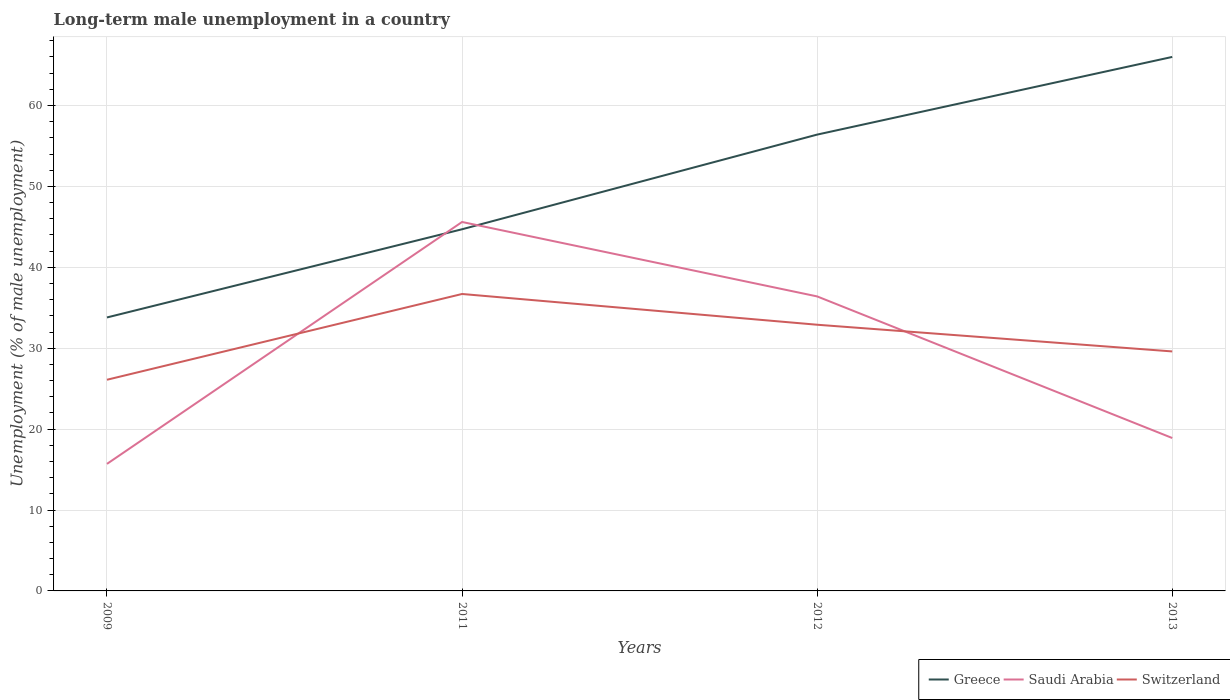Does the line corresponding to Saudi Arabia intersect with the line corresponding to Switzerland?
Give a very brief answer. Yes. Is the number of lines equal to the number of legend labels?
Provide a short and direct response. Yes. Across all years, what is the maximum percentage of long-term unemployed male population in Saudi Arabia?
Your response must be concise. 15.7. What is the total percentage of long-term unemployed male population in Greece in the graph?
Make the answer very short. -21.3. What is the difference between the highest and the second highest percentage of long-term unemployed male population in Switzerland?
Give a very brief answer. 10.6. How many lines are there?
Your response must be concise. 3. Does the graph contain any zero values?
Provide a succinct answer. No. Where does the legend appear in the graph?
Your answer should be very brief. Bottom right. How many legend labels are there?
Offer a terse response. 3. What is the title of the graph?
Provide a short and direct response. Long-term male unemployment in a country. What is the label or title of the X-axis?
Ensure brevity in your answer.  Years. What is the label or title of the Y-axis?
Provide a succinct answer. Unemployment (% of male unemployment). What is the Unemployment (% of male unemployment) of Greece in 2009?
Make the answer very short. 33.8. What is the Unemployment (% of male unemployment) in Saudi Arabia in 2009?
Provide a short and direct response. 15.7. What is the Unemployment (% of male unemployment) of Switzerland in 2009?
Provide a short and direct response. 26.1. What is the Unemployment (% of male unemployment) in Greece in 2011?
Your response must be concise. 44.7. What is the Unemployment (% of male unemployment) in Saudi Arabia in 2011?
Your answer should be compact. 45.6. What is the Unemployment (% of male unemployment) in Switzerland in 2011?
Provide a short and direct response. 36.7. What is the Unemployment (% of male unemployment) in Greece in 2012?
Ensure brevity in your answer.  56.4. What is the Unemployment (% of male unemployment) in Saudi Arabia in 2012?
Offer a very short reply. 36.4. What is the Unemployment (% of male unemployment) in Switzerland in 2012?
Provide a short and direct response. 32.9. What is the Unemployment (% of male unemployment) of Greece in 2013?
Give a very brief answer. 66. What is the Unemployment (% of male unemployment) in Saudi Arabia in 2013?
Provide a succinct answer. 18.9. What is the Unemployment (% of male unemployment) in Switzerland in 2013?
Give a very brief answer. 29.6. Across all years, what is the maximum Unemployment (% of male unemployment) of Greece?
Provide a short and direct response. 66. Across all years, what is the maximum Unemployment (% of male unemployment) of Saudi Arabia?
Provide a short and direct response. 45.6. Across all years, what is the maximum Unemployment (% of male unemployment) of Switzerland?
Provide a short and direct response. 36.7. Across all years, what is the minimum Unemployment (% of male unemployment) in Greece?
Ensure brevity in your answer.  33.8. Across all years, what is the minimum Unemployment (% of male unemployment) of Saudi Arabia?
Keep it short and to the point. 15.7. Across all years, what is the minimum Unemployment (% of male unemployment) in Switzerland?
Offer a very short reply. 26.1. What is the total Unemployment (% of male unemployment) of Greece in the graph?
Give a very brief answer. 200.9. What is the total Unemployment (% of male unemployment) of Saudi Arabia in the graph?
Offer a terse response. 116.6. What is the total Unemployment (% of male unemployment) in Switzerland in the graph?
Provide a short and direct response. 125.3. What is the difference between the Unemployment (% of male unemployment) in Greece in 2009 and that in 2011?
Keep it short and to the point. -10.9. What is the difference between the Unemployment (% of male unemployment) of Saudi Arabia in 2009 and that in 2011?
Offer a terse response. -29.9. What is the difference between the Unemployment (% of male unemployment) in Greece in 2009 and that in 2012?
Provide a succinct answer. -22.6. What is the difference between the Unemployment (% of male unemployment) of Saudi Arabia in 2009 and that in 2012?
Offer a terse response. -20.7. What is the difference between the Unemployment (% of male unemployment) in Greece in 2009 and that in 2013?
Your answer should be compact. -32.2. What is the difference between the Unemployment (% of male unemployment) of Saudi Arabia in 2009 and that in 2013?
Offer a terse response. -3.2. What is the difference between the Unemployment (% of male unemployment) in Switzerland in 2009 and that in 2013?
Your response must be concise. -3.5. What is the difference between the Unemployment (% of male unemployment) in Saudi Arabia in 2011 and that in 2012?
Provide a succinct answer. 9.2. What is the difference between the Unemployment (% of male unemployment) in Greece in 2011 and that in 2013?
Your answer should be very brief. -21.3. What is the difference between the Unemployment (% of male unemployment) in Saudi Arabia in 2011 and that in 2013?
Ensure brevity in your answer.  26.7. What is the difference between the Unemployment (% of male unemployment) of Greece in 2012 and that in 2013?
Offer a terse response. -9.6. What is the difference between the Unemployment (% of male unemployment) in Saudi Arabia in 2012 and that in 2013?
Keep it short and to the point. 17.5. What is the difference between the Unemployment (% of male unemployment) in Greece in 2009 and the Unemployment (% of male unemployment) in Switzerland in 2011?
Keep it short and to the point. -2.9. What is the difference between the Unemployment (% of male unemployment) of Greece in 2009 and the Unemployment (% of male unemployment) of Saudi Arabia in 2012?
Offer a very short reply. -2.6. What is the difference between the Unemployment (% of male unemployment) in Greece in 2009 and the Unemployment (% of male unemployment) in Switzerland in 2012?
Your answer should be compact. 0.9. What is the difference between the Unemployment (% of male unemployment) in Saudi Arabia in 2009 and the Unemployment (% of male unemployment) in Switzerland in 2012?
Make the answer very short. -17.2. What is the difference between the Unemployment (% of male unemployment) in Greece in 2009 and the Unemployment (% of male unemployment) in Saudi Arabia in 2013?
Your answer should be very brief. 14.9. What is the difference between the Unemployment (% of male unemployment) in Saudi Arabia in 2009 and the Unemployment (% of male unemployment) in Switzerland in 2013?
Ensure brevity in your answer.  -13.9. What is the difference between the Unemployment (% of male unemployment) of Greece in 2011 and the Unemployment (% of male unemployment) of Saudi Arabia in 2012?
Offer a very short reply. 8.3. What is the difference between the Unemployment (% of male unemployment) in Greece in 2011 and the Unemployment (% of male unemployment) in Switzerland in 2012?
Your response must be concise. 11.8. What is the difference between the Unemployment (% of male unemployment) of Greece in 2011 and the Unemployment (% of male unemployment) of Saudi Arabia in 2013?
Keep it short and to the point. 25.8. What is the difference between the Unemployment (% of male unemployment) of Greece in 2011 and the Unemployment (% of male unemployment) of Switzerland in 2013?
Give a very brief answer. 15.1. What is the difference between the Unemployment (% of male unemployment) of Saudi Arabia in 2011 and the Unemployment (% of male unemployment) of Switzerland in 2013?
Ensure brevity in your answer.  16. What is the difference between the Unemployment (% of male unemployment) of Greece in 2012 and the Unemployment (% of male unemployment) of Saudi Arabia in 2013?
Your answer should be compact. 37.5. What is the difference between the Unemployment (% of male unemployment) in Greece in 2012 and the Unemployment (% of male unemployment) in Switzerland in 2013?
Offer a very short reply. 26.8. What is the difference between the Unemployment (% of male unemployment) in Saudi Arabia in 2012 and the Unemployment (% of male unemployment) in Switzerland in 2013?
Provide a succinct answer. 6.8. What is the average Unemployment (% of male unemployment) of Greece per year?
Ensure brevity in your answer.  50.23. What is the average Unemployment (% of male unemployment) of Saudi Arabia per year?
Offer a very short reply. 29.15. What is the average Unemployment (% of male unemployment) of Switzerland per year?
Make the answer very short. 31.32. In the year 2009, what is the difference between the Unemployment (% of male unemployment) in Greece and Unemployment (% of male unemployment) in Saudi Arabia?
Ensure brevity in your answer.  18.1. In the year 2009, what is the difference between the Unemployment (% of male unemployment) of Greece and Unemployment (% of male unemployment) of Switzerland?
Make the answer very short. 7.7. In the year 2011, what is the difference between the Unemployment (% of male unemployment) of Greece and Unemployment (% of male unemployment) of Switzerland?
Make the answer very short. 8. In the year 2013, what is the difference between the Unemployment (% of male unemployment) of Greece and Unemployment (% of male unemployment) of Saudi Arabia?
Your answer should be compact. 47.1. In the year 2013, what is the difference between the Unemployment (% of male unemployment) in Greece and Unemployment (% of male unemployment) in Switzerland?
Offer a very short reply. 36.4. What is the ratio of the Unemployment (% of male unemployment) of Greece in 2009 to that in 2011?
Give a very brief answer. 0.76. What is the ratio of the Unemployment (% of male unemployment) in Saudi Arabia in 2009 to that in 2011?
Make the answer very short. 0.34. What is the ratio of the Unemployment (% of male unemployment) of Switzerland in 2009 to that in 2011?
Ensure brevity in your answer.  0.71. What is the ratio of the Unemployment (% of male unemployment) in Greece in 2009 to that in 2012?
Offer a terse response. 0.6. What is the ratio of the Unemployment (% of male unemployment) in Saudi Arabia in 2009 to that in 2012?
Offer a terse response. 0.43. What is the ratio of the Unemployment (% of male unemployment) of Switzerland in 2009 to that in 2012?
Give a very brief answer. 0.79. What is the ratio of the Unemployment (% of male unemployment) in Greece in 2009 to that in 2013?
Ensure brevity in your answer.  0.51. What is the ratio of the Unemployment (% of male unemployment) of Saudi Arabia in 2009 to that in 2013?
Your answer should be very brief. 0.83. What is the ratio of the Unemployment (% of male unemployment) of Switzerland in 2009 to that in 2013?
Your answer should be compact. 0.88. What is the ratio of the Unemployment (% of male unemployment) in Greece in 2011 to that in 2012?
Offer a very short reply. 0.79. What is the ratio of the Unemployment (% of male unemployment) in Saudi Arabia in 2011 to that in 2012?
Provide a short and direct response. 1.25. What is the ratio of the Unemployment (% of male unemployment) of Switzerland in 2011 to that in 2012?
Your response must be concise. 1.12. What is the ratio of the Unemployment (% of male unemployment) in Greece in 2011 to that in 2013?
Offer a very short reply. 0.68. What is the ratio of the Unemployment (% of male unemployment) in Saudi Arabia in 2011 to that in 2013?
Your response must be concise. 2.41. What is the ratio of the Unemployment (% of male unemployment) in Switzerland in 2011 to that in 2013?
Give a very brief answer. 1.24. What is the ratio of the Unemployment (% of male unemployment) of Greece in 2012 to that in 2013?
Keep it short and to the point. 0.85. What is the ratio of the Unemployment (% of male unemployment) in Saudi Arabia in 2012 to that in 2013?
Your answer should be very brief. 1.93. What is the ratio of the Unemployment (% of male unemployment) in Switzerland in 2012 to that in 2013?
Your answer should be very brief. 1.11. What is the difference between the highest and the second highest Unemployment (% of male unemployment) in Saudi Arabia?
Provide a succinct answer. 9.2. What is the difference between the highest and the lowest Unemployment (% of male unemployment) in Greece?
Provide a short and direct response. 32.2. What is the difference between the highest and the lowest Unemployment (% of male unemployment) of Saudi Arabia?
Make the answer very short. 29.9. 